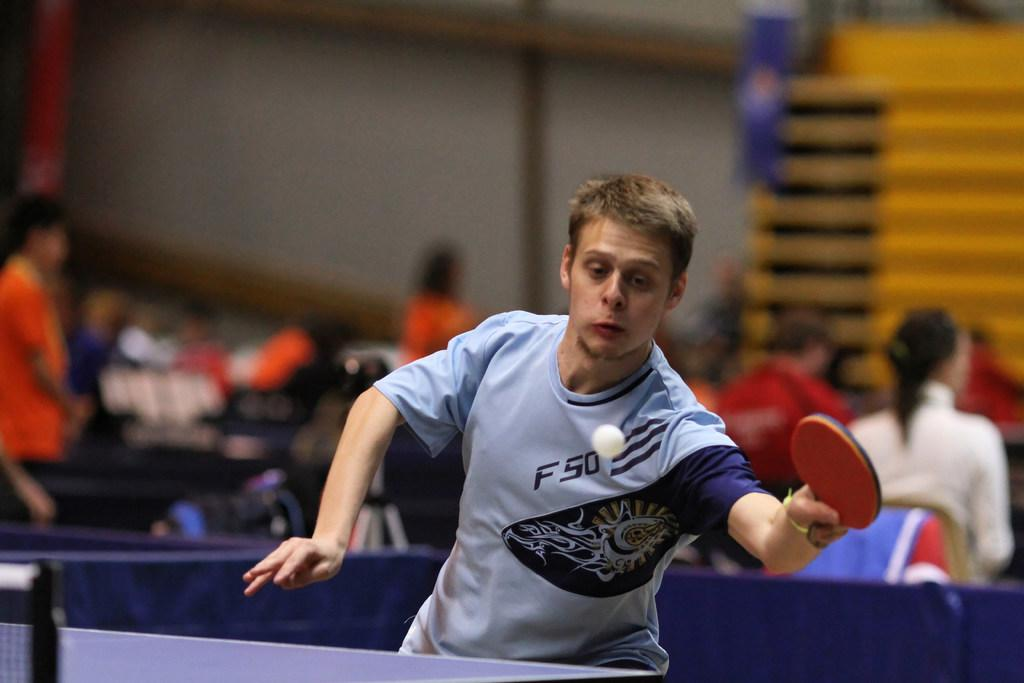Provide a one-sentence caption for the provided image. A man is about to hit a ball with a paddle and has the letter f on his shirt. 